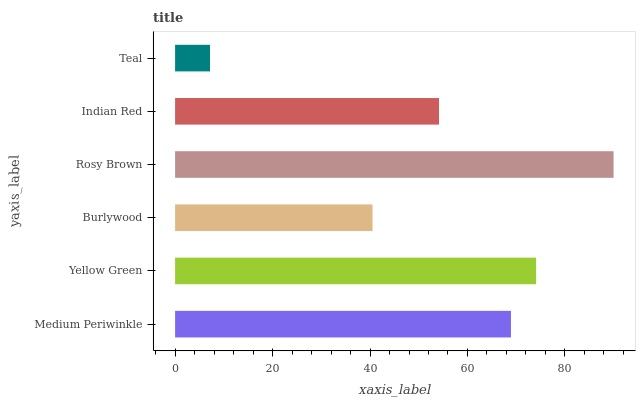Is Teal the minimum?
Answer yes or no. Yes. Is Rosy Brown the maximum?
Answer yes or no. Yes. Is Yellow Green the minimum?
Answer yes or no. No. Is Yellow Green the maximum?
Answer yes or no. No. Is Yellow Green greater than Medium Periwinkle?
Answer yes or no. Yes. Is Medium Periwinkle less than Yellow Green?
Answer yes or no. Yes. Is Medium Periwinkle greater than Yellow Green?
Answer yes or no. No. Is Yellow Green less than Medium Periwinkle?
Answer yes or no. No. Is Medium Periwinkle the high median?
Answer yes or no. Yes. Is Indian Red the low median?
Answer yes or no. Yes. Is Teal the high median?
Answer yes or no. No. Is Teal the low median?
Answer yes or no. No. 